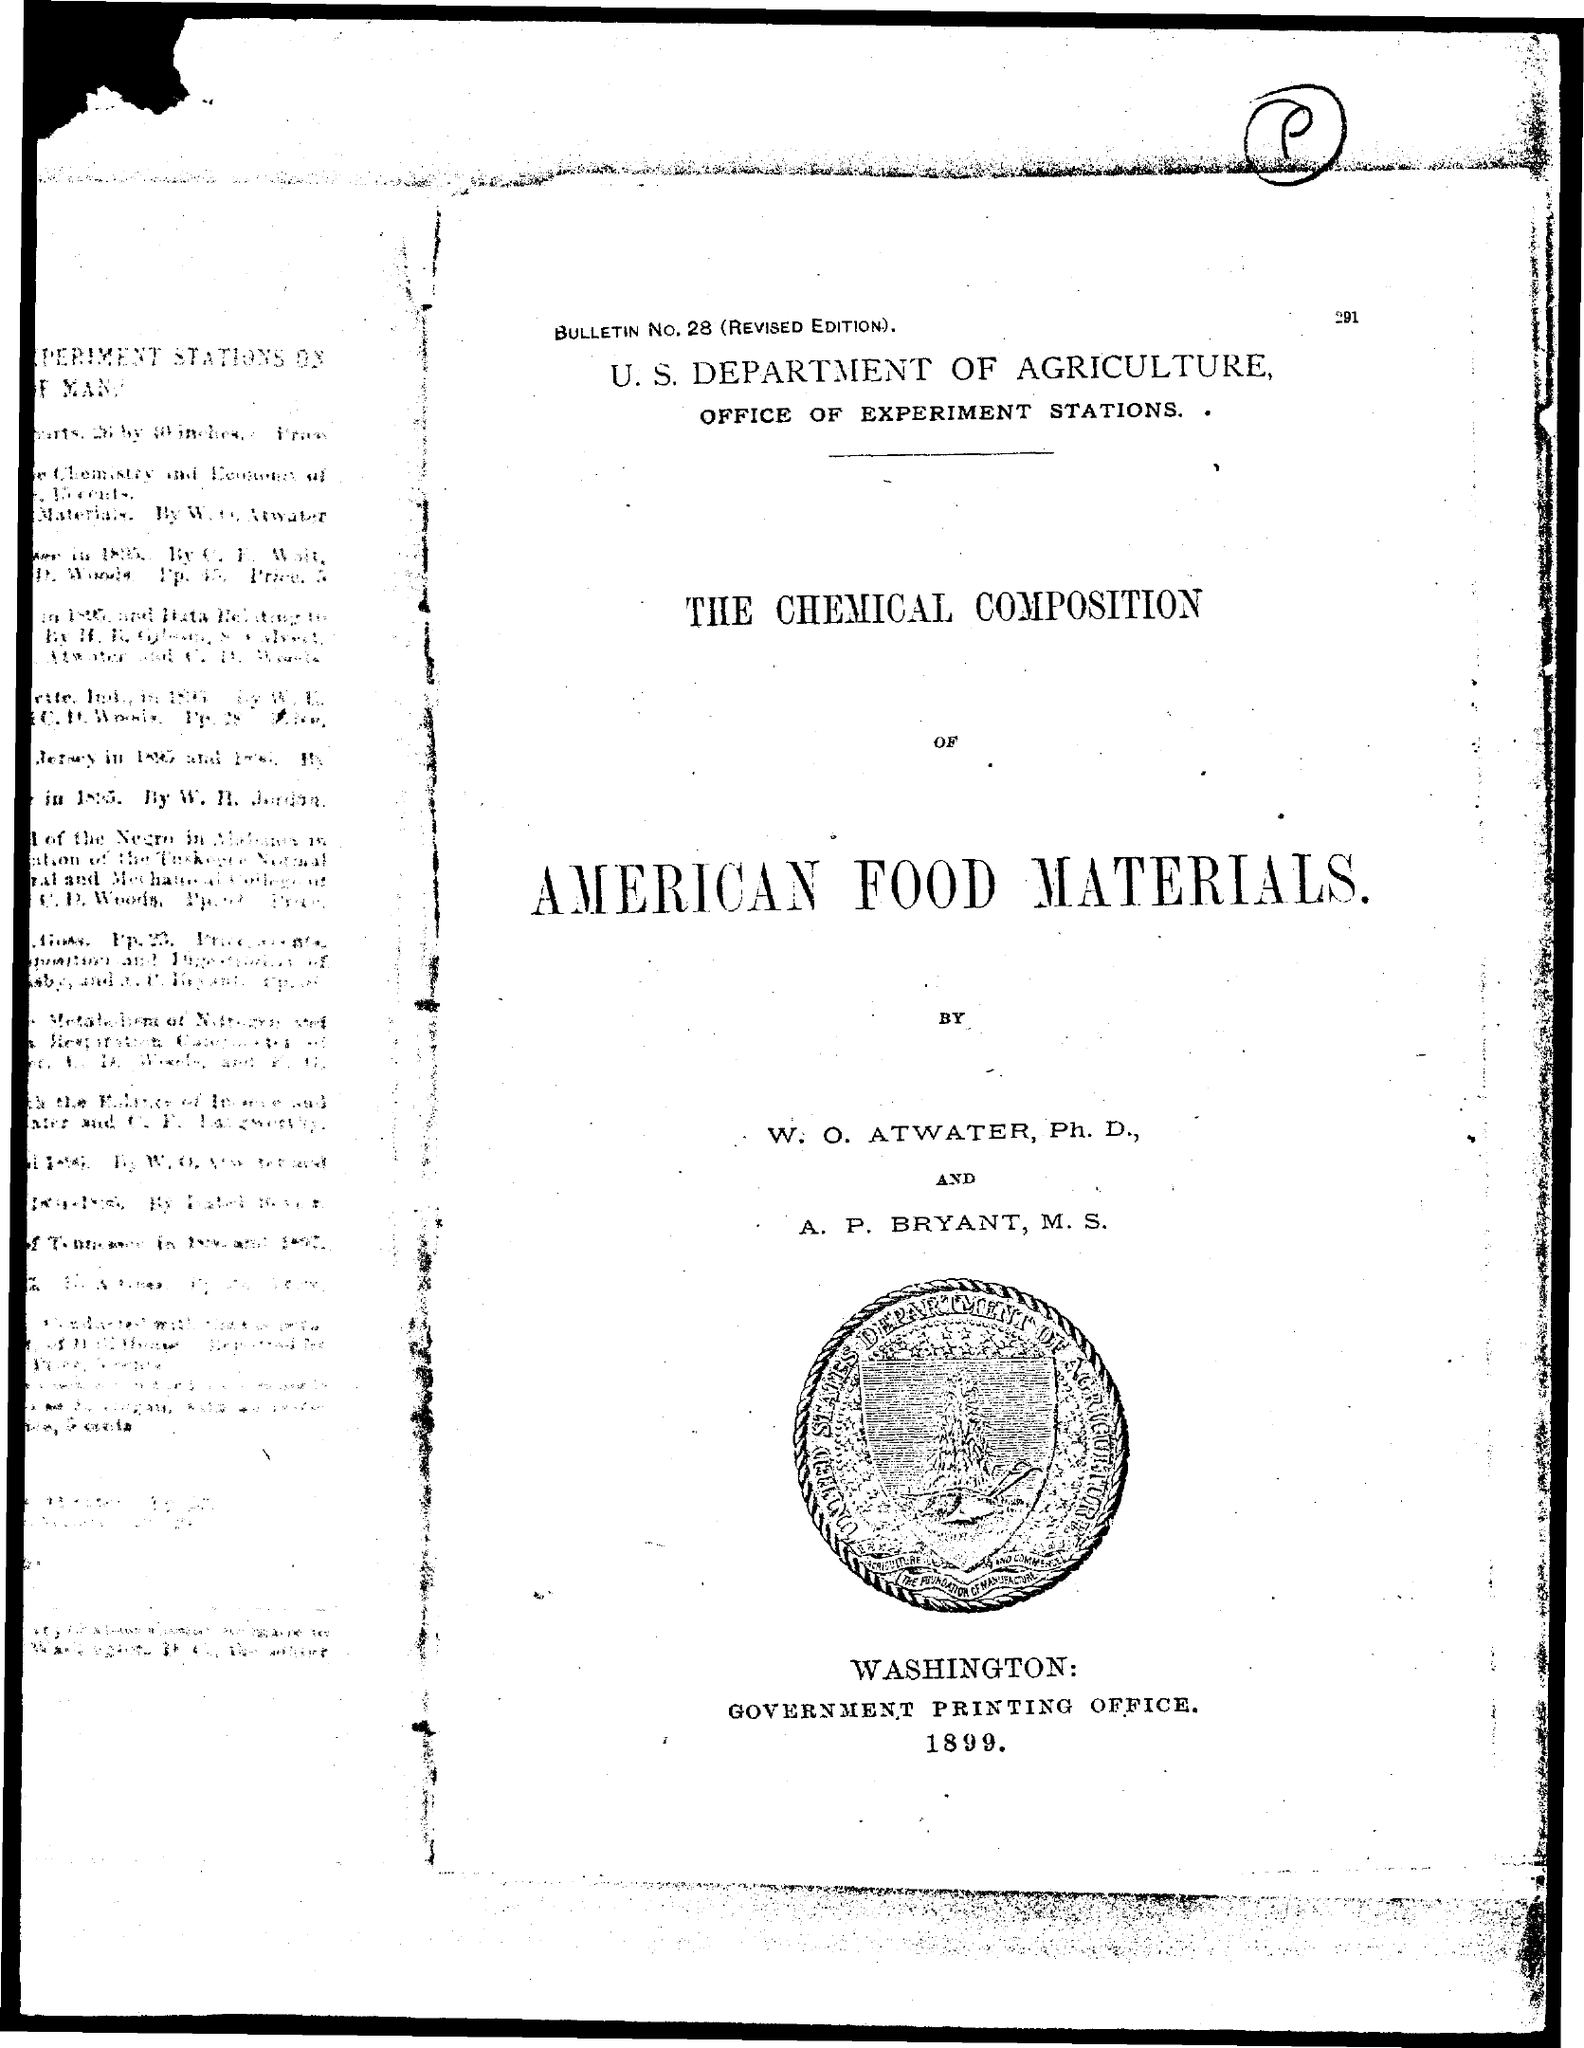Mention a couple of crucial points in this snapshot. The Government Printing Office is located in Washington. The Bulletin Number is 28. 